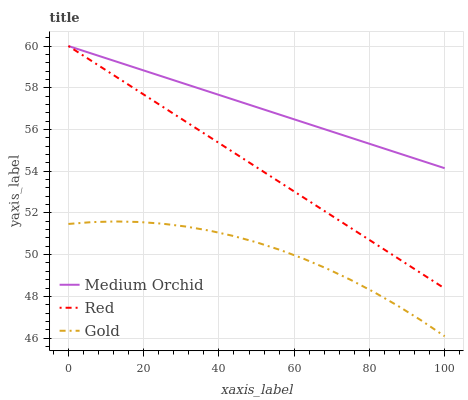Does Gold have the minimum area under the curve?
Answer yes or no. Yes. Does Medium Orchid have the maximum area under the curve?
Answer yes or no. Yes. Does Red have the minimum area under the curve?
Answer yes or no. No. Does Red have the maximum area under the curve?
Answer yes or no. No. Is Medium Orchid the smoothest?
Answer yes or no. Yes. Is Gold the roughest?
Answer yes or no. Yes. Is Red the smoothest?
Answer yes or no. No. Is Red the roughest?
Answer yes or no. No. Does Gold have the lowest value?
Answer yes or no. Yes. Does Red have the lowest value?
Answer yes or no. No. Does Red have the highest value?
Answer yes or no. Yes. Does Gold have the highest value?
Answer yes or no. No. Is Gold less than Red?
Answer yes or no. Yes. Is Red greater than Gold?
Answer yes or no. Yes. Does Medium Orchid intersect Red?
Answer yes or no. Yes. Is Medium Orchid less than Red?
Answer yes or no. No. Is Medium Orchid greater than Red?
Answer yes or no. No. Does Gold intersect Red?
Answer yes or no. No. 